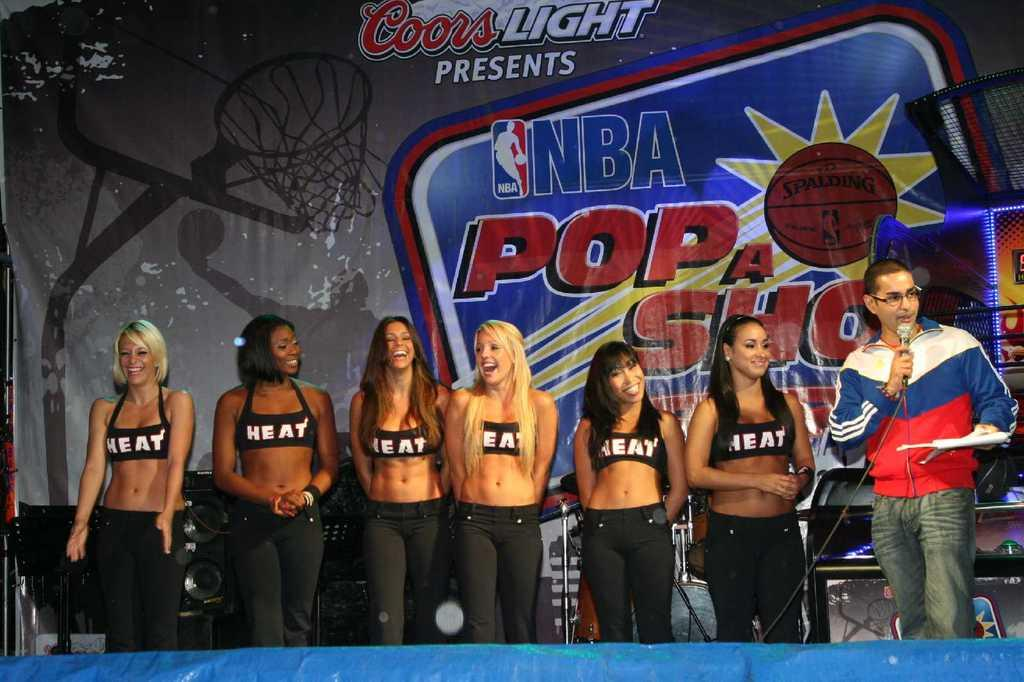<image>
Share a concise interpretation of the image provided. a row of young women in sports bras standing in front of NBA's Pop a Shot. 